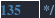<code> <loc_0><loc_0><loc_500><loc_500><_CSS_> */
</code> 